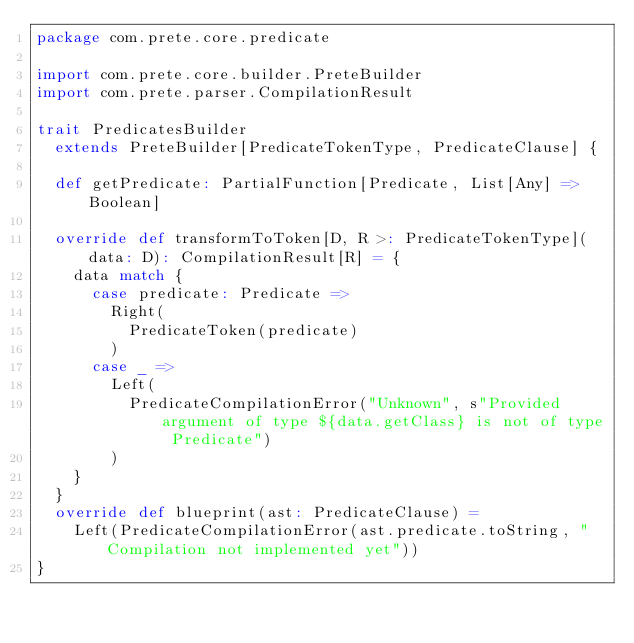<code> <loc_0><loc_0><loc_500><loc_500><_Scala_>package com.prete.core.predicate

import com.prete.core.builder.PreteBuilder
import com.prete.parser.CompilationResult

trait PredicatesBuilder
  extends PreteBuilder[PredicateTokenType, PredicateClause] {

  def getPredicate: PartialFunction[Predicate, List[Any] => Boolean]

  override def transformToToken[D, R >: PredicateTokenType](data: D): CompilationResult[R] = {
    data match {
      case predicate: Predicate =>
        Right(
          PredicateToken(predicate)
        )
      case _ =>
        Left(
          PredicateCompilationError("Unknown", s"Provided argument of type ${data.getClass} is not of type Predicate")
        )
    }
  }
  override def blueprint(ast: PredicateClause) =
    Left(PredicateCompilationError(ast.predicate.toString, "Compilation not implemented yet"))
}</code> 